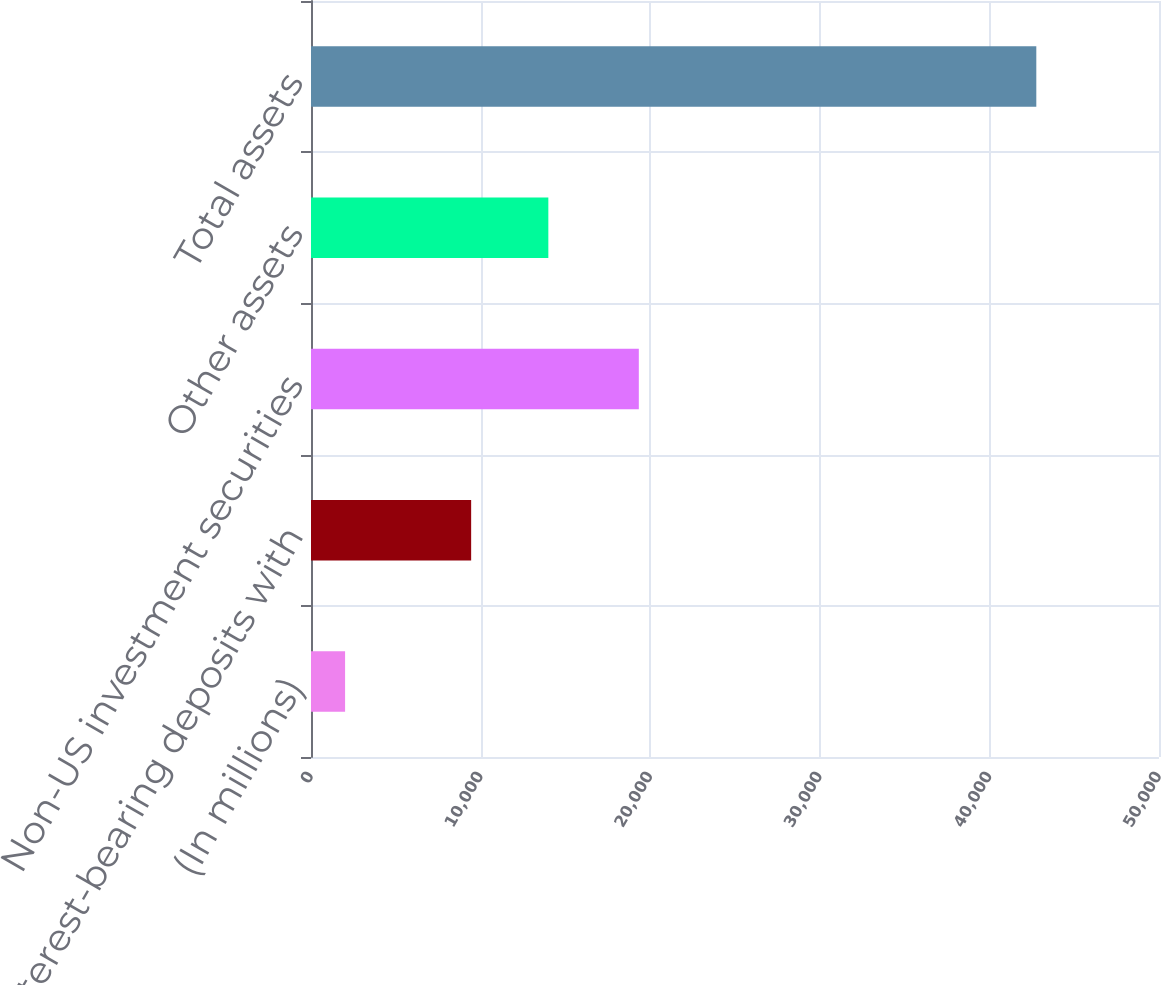<chart> <loc_0><loc_0><loc_500><loc_500><bar_chart><fcel>(In millions)<fcel>Interest-bearing deposits with<fcel>Non-US investment securities<fcel>Other assets<fcel>Total assets<nl><fcel>2010<fcel>9443<fcel>19329<fcel>13994<fcel>42766<nl></chart> 